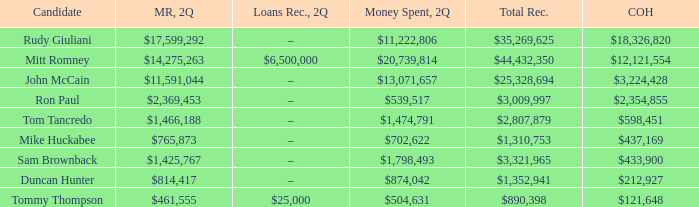Name the money raised when 2Q has money spent and 2Q is $874,042 $814,417. 